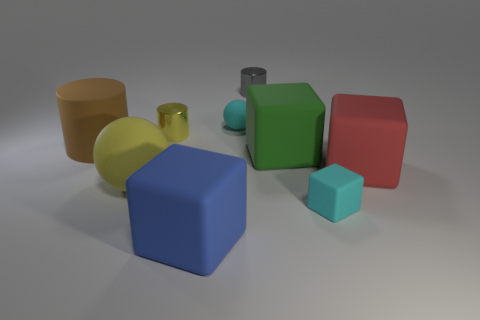Subtract all rubber cylinders. How many cylinders are left? 2 Add 1 green objects. How many objects exist? 10 Subtract all red blocks. How many blocks are left? 3 Subtract 2 blocks. How many blocks are left? 2 Subtract all green cylinders. Subtract all brown cubes. How many cylinders are left? 3 Subtract all cylinders. How many objects are left? 6 Add 9 large green blocks. How many large green blocks exist? 10 Subtract 1 gray cylinders. How many objects are left? 8 Subtract all large red rubber things. Subtract all blue objects. How many objects are left? 7 Add 4 large brown things. How many large brown things are left? 5 